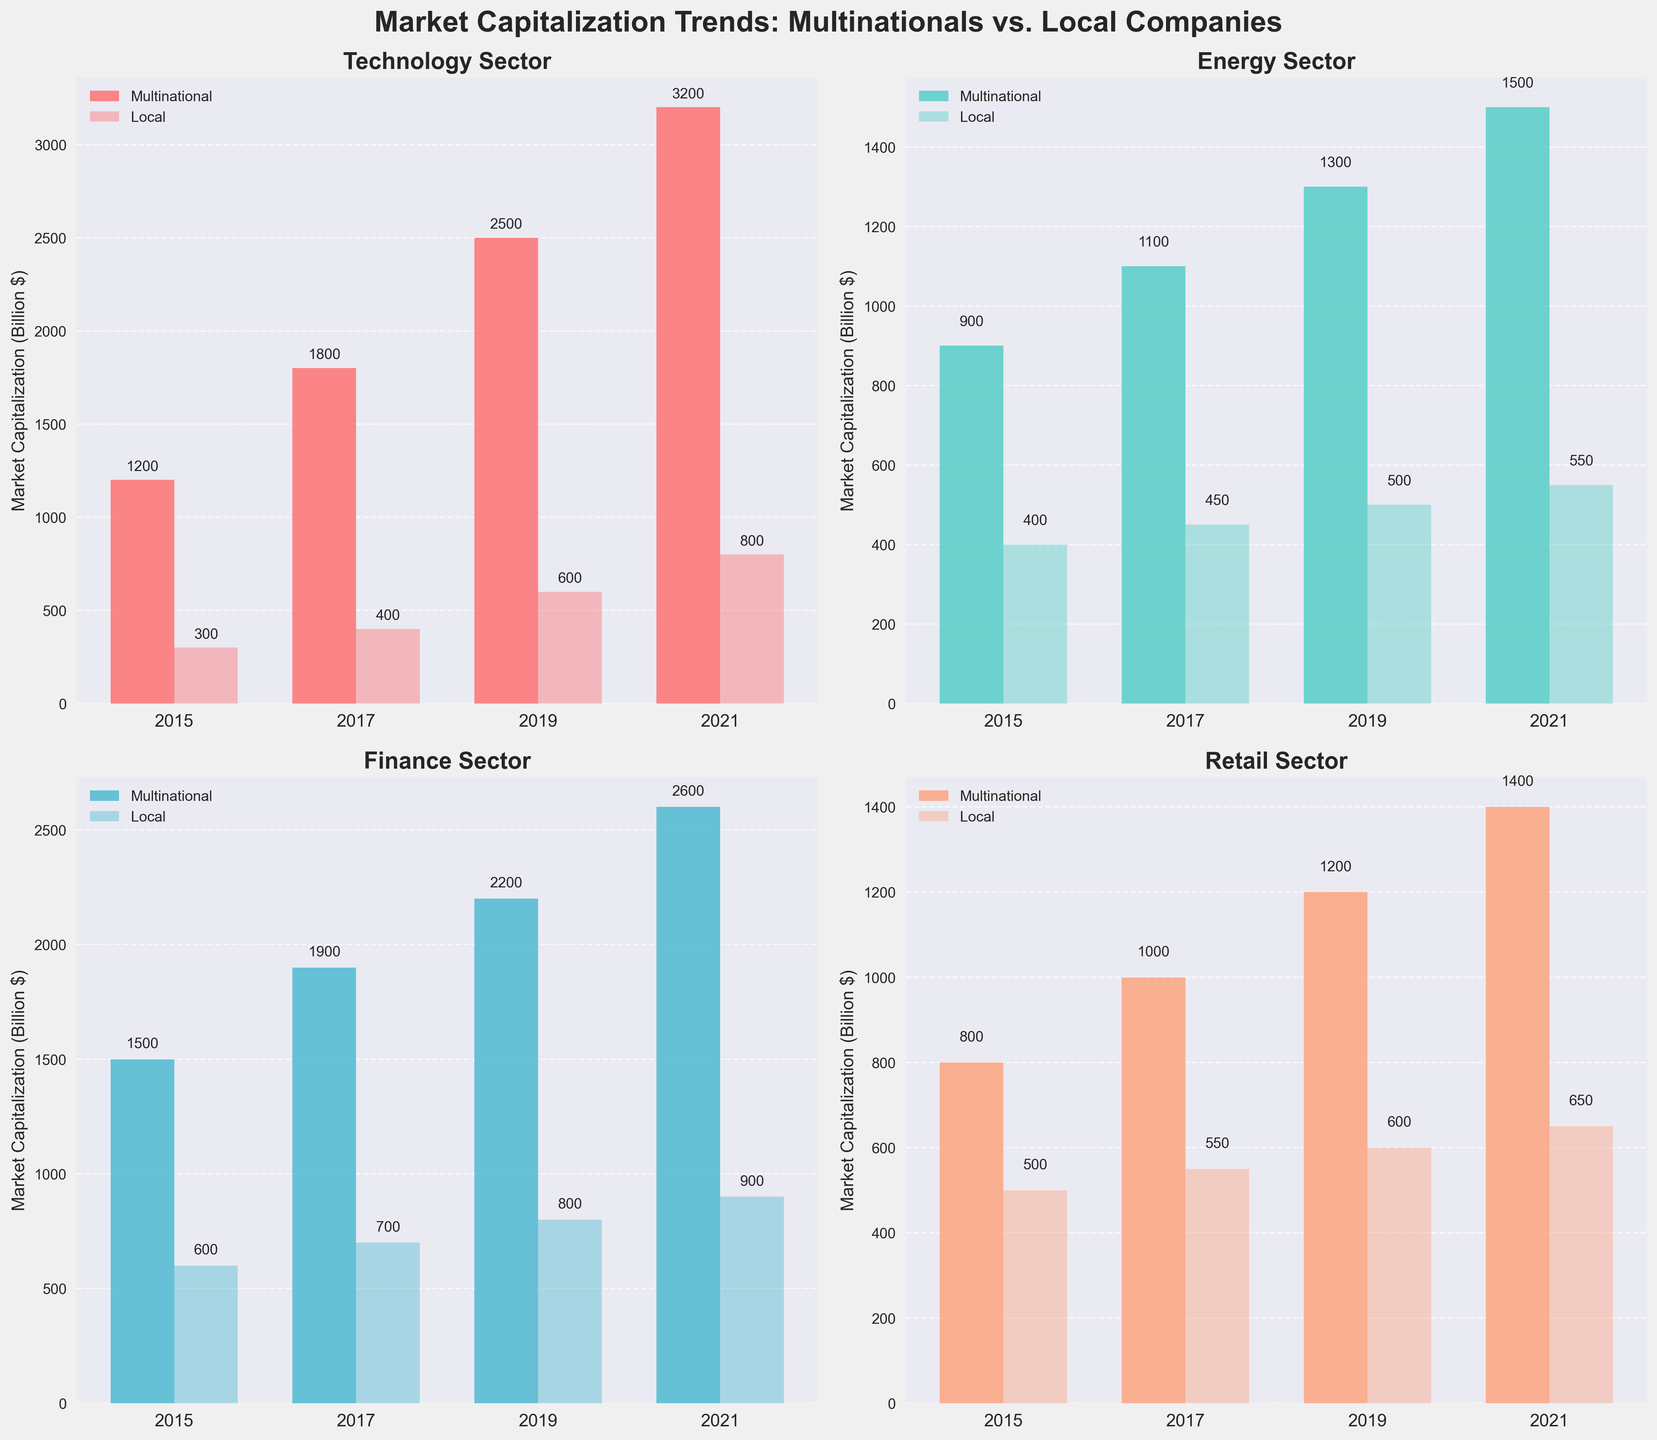What is the title of the figure? The title of the figure is located at the top and it reads "Market Capitalization Trends: Multinationals vs. Local Companies".
Answer: Market Capitalization Trends: Multinationals vs. Local Companies What is the market capitalization of multinational corporations in the Technology sector in 2021? In the Technology sector subplot, the bar representing "Multinational" for the year 2021 has a label above showing 3200.
Answer: 3200 How did the market capitalization of local companies in the Retail sector change from 2015 to 2021? In the Retail sector subplot, compare the height and values of the "Local" bars for 2015 and 2021. It increased from 500 in 2015 to 650 in 2021.
Answer: Increased by 150 In which sector did multinational corporations see the largest increase in market capitalization from 2015 to 2021? Compare the changes in the height and labels of the "Multinational" bars across all sectors from 2015 to 2021. The Technology sector increased from 1200 to 3200, a rise of 2000, which is larger than any other sector's increase.
Answer: Technology Which sector had the closest market capitalization between multinational and local companies in 2017? Compare the heights of the "Multinational" and "Local" bars for all sectors in 2017. The Finance sector has multinational at 1900 and local at 700, a difference of 1200 which is the smallest among the sectors.
Answer: Finance What is the total market capitalization for local companies across all sectors in 2019? Sum the market capitalizations of local companies in all sectors for 2019: 600 (Technology) + 500 (Energy) + 800 (Finance) + 600 (Retail) = 2500.
Answer: 2500 Which year shows the largest overall market capitalization for multinational corporations in the Energy sector? Compare the values of the "Multinational" bars in the Energy sector across all years. The highest value is 1500 in 2021.
Answer: 2021 Have local companies in the Technology sector grown consistently over the years? Check the trend of "Local" bars in the Technology sector across all years. The values are 300, 400, 600, 800, showing a consistent growth.
Answer: Yes Between multinational and local companies, who had a higher market capitalization in the Finance sector in 2015? In the Finance sector for 2015, compare the "Multinational" bar (1500) with the "Local" bar (600). The multinational corporations had a higher market capitalization.
Answer: Multinational corporations 